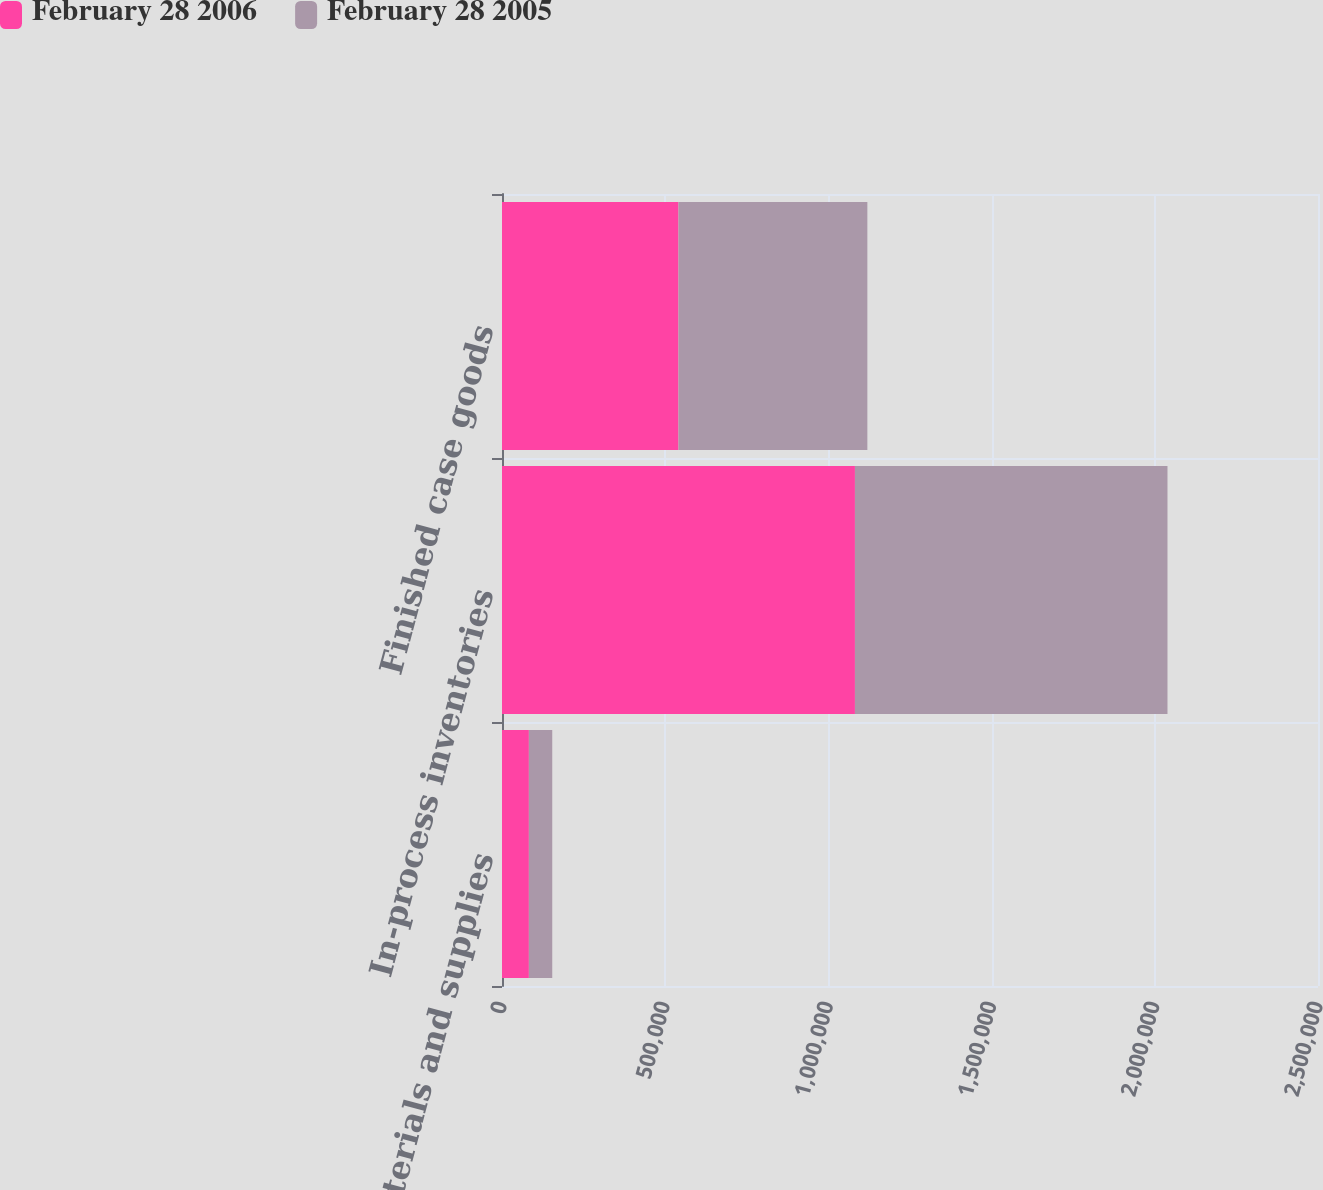Convert chart. <chart><loc_0><loc_0><loc_500><loc_500><stacked_bar_chart><ecel><fcel>Raw materials and supplies<fcel>In-process inventories<fcel>Finished case goods<nl><fcel>February 28 2006<fcel>82366<fcel>1.0813e+06<fcel>540762<nl><fcel>February 28 2005<fcel>71562<fcel>957567<fcel>578606<nl></chart> 